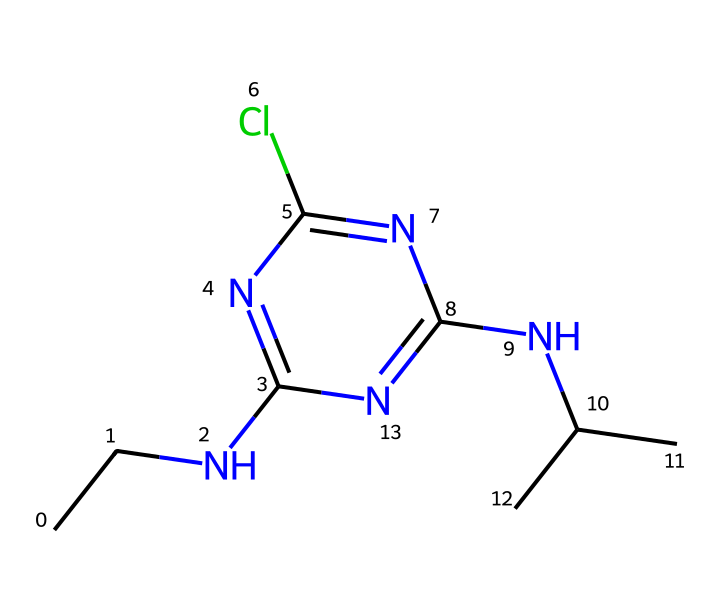What is the molecular formula of atrazine? The molecular formula can be derived from counting the various atoms in the chemical structure represented by its SMILES. It shows a total of 9 carbon (C) atoms, 14 hydrogen (H) atoms, 4 nitrogen (N) atoms, and 1 chlorine (Cl) atom. Therefore, the molecular formula is C8H14ClN5.
Answer: C8H14ClN5 How many nitrogen atoms are present in atrazine? By examining the SMILES representation, we can identify the number of nitrogen (N) atoms. The chemical structure shows 4 nitrogen atoms integrated within the triazine core.
Answer: 4 What type of herbicide is atrazine classified as? Atrazine is classified based on its chemical structure and activity in agriculture. It has a triazine ring structure that fits the criteria for selective herbicides that inhibit photosynthesis.
Answer: triazine herbicide What functional groups are present in atrazine? Analyzing the structure reveals the presence of multiple functional groups, specifically: a secondary amine (due to the -NH group), and a nitrogen-containing heterocyclic compound (the triazine ring).
Answer: secondary amine and triazine ring Is atrazine a systemic or contact herbicide? Understanding the mode of action based on the structure helps determine its classification as systemic. Atrazine is absorbed by plant roots and leaves, leading to its herbicidal effect throughout the plant.
Answer: systemic What property of atrazine allows it to be effective against broadleaf weeds? The specific interaction of atrazine with the photosystem II during photosynthesis is responsible for its effectiveness. Its chemical structure allows it to bind to the D1 protein in the photosystem, disrupting energy transfer.
Answer: photosystem II inhibitor 